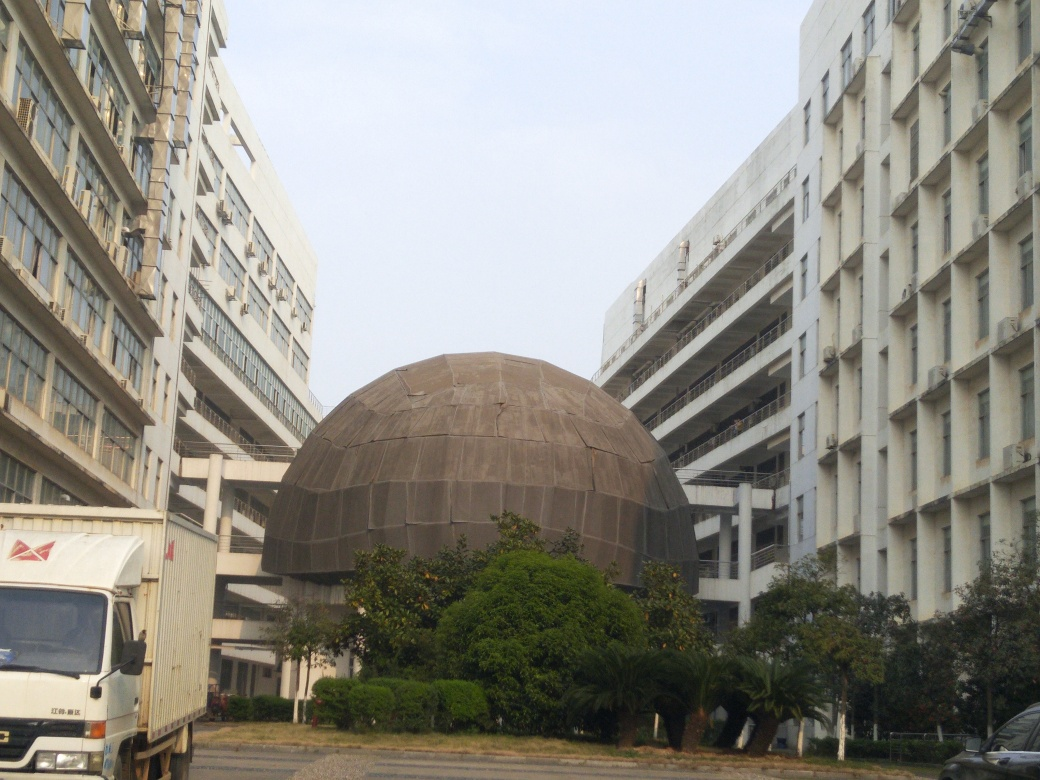Could this dome structure serve any specific function based on its design? The dome structure might serve as a venue for various activities, such as a theater, planetarium, or exhibition space. Its spherical shape is excellent for acoustics, which is ideal for performances or lectures. Also, the enclosed, unobstructed interior space provided by a dome is perfect for exhibits and installations that require a large, open area. 